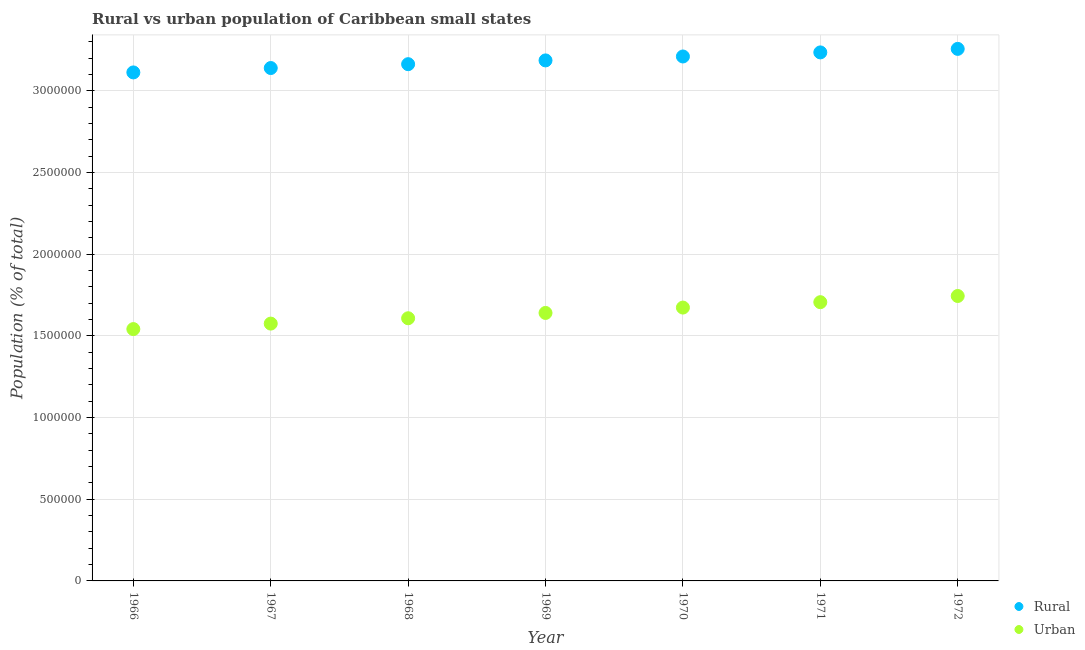What is the rural population density in 1967?
Your response must be concise. 3.14e+06. Across all years, what is the maximum urban population density?
Offer a very short reply. 1.74e+06. Across all years, what is the minimum urban population density?
Offer a terse response. 1.54e+06. In which year was the urban population density minimum?
Your answer should be very brief. 1966. What is the total urban population density in the graph?
Provide a succinct answer. 1.15e+07. What is the difference between the rural population density in 1968 and that in 1972?
Ensure brevity in your answer.  -9.36e+04. What is the difference between the urban population density in 1968 and the rural population density in 1969?
Offer a terse response. -1.58e+06. What is the average rural population density per year?
Your answer should be compact. 3.19e+06. In the year 1970, what is the difference between the rural population density and urban population density?
Provide a short and direct response. 1.54e+06. What is the ratio of the rural population density in 1969 to that in 1972?
Your response must be concise. 0.98. Is the urban population density in 1966 less than that in 1967?
Offer a terse response. Yes. What is the difference between the highest and the second highest rural population density?
Your answer should be very brief. 2.15e+04. What is the difference between the highest and the lowest urban population density?
Your response must be concise. 2.03e+05. In how many years, is the urban population density greater than the average urban population density taken over all years?
Offer a very short reply. 3. Is the sum of the rural population density in 1971 and 1972 greater than the maximum urban population density across all years?
Your answer should be very brief. Yes. Does the rural population density monotonically increase over the years?
Offer a terse response. Yes. How many dotlines are there?
Provide a short and direct response. 2. How many years are there in the graph?
Your answer should be compact. 7. What is the difference between two consecutive major ticks on the Y-axis?
Provide a succinct answer. 5.00e+05. Are the values on the major ticks of Y-axis written in scientific E-notation?
Keep it short and to the point. No. Where does the legend appear in the graph?
Make the answer very short. Bottom right. How many legend labels are there?
Give a very brief answer. 2. How are the legend labels stacked?
Make the answer very short. Vertical. What is the title of the graph?
Offer a terse response. Rural vs urban population of Caribbean small states. Does "Electricity" appear as one of the legend labels in the graph?
Provide a succinct answer. No. What is the label or title of the X-axis?
Give a very brief answer. Year. What is the label or title of the Y-axis?
Offer a very short reply. Population (% of total). What is the Population (% of total) in Rural in 1966?
Ensure brevity in your answer.  3.11e+06. What is the Population (% of total) of Urban in 1966?
Offer a very short reply. 1.54e+06. What is the Population (% of total) of Rural in 1967?
Provide a succinct answer. 3.14e+06. What is the Population (% of total) in Urban in 1967?
Offer a very short reply. 1.57e+06. What is the Population (% of total) of Rural in 1968?
Your response must be concise. 3.16e+06. What is the Population (% of total) of Urban in 1968?
Offer a very short reply. 1.61e+06. What is the Population (% of total) of Rural in 1969?
Provide a short and direct response. 3.19e+06. What is the Population (% of total) of Urban in 1969?
Make the answer very short. 1.64e+06. What is the Population (% of total) of Rural in 1970?
Ensure brevity in your answer.  3.21e+06. What is the Population (% of total) in Urban in 1970?
Make the answer very short. 1.67e+06. What is the Population (% of total) in Rural in 1971?
Offer a very short reply. 3.23e+06. What is the Population (% of total) in Urban in 1971?
Offer a terse response. 1.71e+06. What is the Population (% of total) in Rural in 1972?
Provide a succinct answer. 3.26e+06. What is the Population (% of total) of Urban in 1972?
Provide a short and direct response. 1.74e+06. Across all years, what is the maximum Population (% of total) of Rural?
Make the answer very short. 3.26e+06. Across all years, what is the maximum Population (% of total) in Urban?
Provide a succinct answer. 1.74e+06. Across all years, what is the minimum Population (% of total) in Rural?
Give a very brief answer. 3.11e+06. Across all years, what is the minimum Population (% of total) of Urban?
Your answer should be very brief. 1.54e+06. What is the total Population (% of total) in Rural in the graph?
Your response must be concise. 2.23e+07. What is the total Population (% of total) of Urban in the graph?
Ensure brevity in your answer.  1.15e+07. What is the difference between the Population (% of total) of Rural in 1966 and that in 1967?
Offer a terse response. -2.69e+04. What is the difference between the Population (% of total) of Urban in 1966 and that in 1967?
Keep it short and to the point. -3.36e+04. What is the difference between the Population (% of total) in Rural in 1966 and that in 1968?
Provide a succinct answer. -5.05e+04. What is the difference between the Population (% of total) of Urban in 1966 and that in 1968?
Make the answer very short. -6.63e+04. What is the difference between the Population (% of total) in Rural in 1966 and that in 1969?
Keep it short and to the point. -7.35e+04. What is the difference between the Population (% of total) of Urban in 1966 and that in 1969?
Ensure brevity in your answer.  -9.88e+04. What is the difference between the Population (% of total) in Rural in 1966 and that in 1970?
Your answer should be very brief. -9.76e+04. What is the difference between the Population (% of total) in Urban in 1966 and that in 1970?
Provide a succinct answer. -1.32e+05. What is the difference between the Population (% of total) in Rural in 1966 and that in 1971?
Offer a terse response. -1.23e+05. What is the difference between the Population (% of total) in Urban in 1966 and that in 1971?
Make the answer very short. -1.65e+05. What is the difference between the Population (% of total) of Rural in 1966 and that in 1972?
Make the answer very short. -1.44e+05. What is the difference between the Population (% of total) in Urban in 1966 and that in 1972?
Your answer should be very brief. -2.03e+05. What is the difference between the Population (% of total) in Rural in 1967 and that in 1968?
Offer a very short reply. -2.36e+04. What is the difference between the Population (% of total) of Urban in 1967 and that in 1968?
Offer a terse response. -3.28e+04. What is the difference between the Population (% of total) in Rural in 1967 and that in 1969?
Make the answer very short. -4.67e+04. What is the difference between the Population (% of total) of Urban in 1967 and that in 1969?
Offer a very short reply. -6.53e+04. What is the difference between the Population (% of total) of Rural in 1967 and that in 1970?
Keep it short and to the point. -7.07e+04. What is the difference between the Population (% of total) in Urban in 1967 and that in 1970?
Provide a succinct answer. -9.81e+04. What is the difference between the Population (% of total) of Rural in 1967 and that in 1971?
Your response must be concise. -9.57e+04. What is the difference between the Population (% of total) of Urban in 1967 and that in 1971?
Make the answer very short. -1.31e+05. What is the difference between the Population (% of total) in Rural in 1967 and that in 1972?
Your response must be concise. -1.17e+05. What is the difference between the Population (% of total) of Urban in 1967 and that in 1972?
Provide a short and direct response. -1.69e+05. What is the difference between the Population (% of total) in Rural in 1968 and that in 1969?
Your response must be concise. -2.31e+04. What is the difference between the Population (% of total) in Urban in 1968 and that in 1969?
Ensure brevity in your answer.  -3.25e+04. What is the difference between the Population (% of total) of Rural in 1968 and that in 1970?
Offer a very short reply. -4.71e+04. What is the difference between the Population (% of total) in Urban in 1968 and that in 1970?
Offer a terse response. -6.54e+04. What is the difference between the Population (% of total) in Rural in 1968 and that in 1971?
Your answer should be very brief. -7.20e+04. What is the difference between the Population (% of total) in Urban in 1968 and that in 1971?
Provide a short and direct response. -9.84e+04. What is the difference between the Population (% of total) in Rural in 1968 and that in 1972?
Your response must be concise. -9.36e+04. What is the difference between the Population (% of total) of Urban in 1968 and that in 1972?
Offer a very short reply. -1.36e+05. What is the difference between the Population (% of total) in Rural in 1969 and that in 1970?
Ensure brevity in your answer.  -2.40e+04. What is the difference between the Population (% of total) in Urban in 1969 and that in 1970?
Give a very brief answer. -3.29e+04. What is the difference between the Population (% of total) in Rural in 1969 and that in 1971?
Provide a short and direct response. -4.90e+04. What is the difference between the Population (% of total) in Urban in 1969 and that in 1971?
Your answer should be very brief. -6.58e+04. What is the difference between the Population (% of total) in Rural in 1969 and that in 1972?
Offer a terse response. -7.05e+04. What is the difference between the Population (% of total) of Urban in 1969 and that in 1972?
Offer a very short reply. -1.04e+05. What is the difference between the Population (% of total) in Rural in 1970 and that in 1971?
Ensure brevity in your answer.  -2.50e+04. What is the difference between the Population (% of total) of Urban in 1970 and that in 1971?
Make the answer very short. -3.30e+04. What is the difference between the Population (% of total) in Rural in 1970 and that in 1972?
Your answer should be very brief. -4.65e+04. What is the difference between the Population (% of total) of Urban in 1970 and that in 1972?
Keep it short and to the point. -7.09e+04. What is the difference between the Population (% of total) in Rural in 1971 and that in 1972?
Your response must be concise. -2.15e+04. What is the difference between the Population (% of total) of Urban in 1971 and that in 1972?
Ensure brevity in your answer.  -3.79e+04. What is the difference between the Population (% of total) of Rural in 1966 and the Population (% of total) of Urban in 1967?
Offer a very short reply. 1.54e+06. What is the difference between the Population (% of total) in Rural in 1966 and the Population (% of total) in Urban in 1968?
Keep it short and to the point. 1.50e+06. What is the difference between the Population (% of total) of Rural in 1966 and the Population (% of total) of Urban in 1969?
Your response must be concise. 1.47e+06. What is the difference between the Population (% of total) of Rural in 1966 and the Population (% of total) of Urban in 1970?
Your response must be concise. 1.44e+06. What is the difference between the Population (% of total) in Rural in 1966 and the Population (% of total) in Urban in 1971?
Offer a terse response. 1.41e+06. What is the difference between the Population (% of total) in Rural in 1966 and the Population (% of total) in Urban in 1972?
Your answer should be compact. 1.37e+06. What is the difference between the Population (% of total) of Rural in 1967 and the Population (% of total) of Urban in 1968?
Give a very brief answer. 1.53e+06. What is the difference between the Population (% of total) of Rural in 1967 and the Population (% of total) of Urban in 1969?
Provide a succinct answer. 1.50e+06. What is the difference between the Population (% of total) in Rural in 1967 and the Population (% of total) in Urban in 1970?
Offer a very short reply. 1.47e+06. What is the difference between the Population (% of total) of Rural in 1967 and the Population (% of total) of Urban in 1971?
Keep it short and to the point. 1.43e+06. What is the difference between the Population (% of total) of Rural in 1967 and the Population (% of total) of Urban in 1972?
Your answer should be very brief. 1.40e+06. What is the difference between the Population (% of total) of Rural in 1968 and the Population (% of total) of Urban in 1969?
Provide a short and direct response. 1.52e+06. What is the difference between the Population (% of total) of Rural in 1968 and the Population (% of total) of Urban in 1970?
Keep it short and to the point. 1.49e+06. What is the difference between the Population (% of total) in Rural in 1968 and the Population (% of total) in Urban in 1971?
Make the answer very short. 1.46e+06. What is the difference between the Population (% of total) of Rural in 1968 and the Population (% of total) of Urban in 1972?
Your response must be concise. 1.42e+06. What is the difference between the Population (% of total) in Rural in 1969 and the Population (% of total) in Urban in 1970?
Offer a very short reply. 1.51e+06. What is the difference between the Population (% of total) in Rural in 1969 and the Population (% of total) in Urban in 1971?
Provide a succinct answer. 1.48e+06. What is the difference between the Population (% of total) of Rural in 1969 and the Population (% of total) of Urban in 1972?
Provide a succinct answer. 1.44e+06. What is the difference between the Population (% of total) of Rural in 1970 and the Population (% of total) of Urban in 1971?
Offer a terse response. 1.50e+06. What is the difference between the Population (% of total) in Rural in 1970 and the Population (% of total) in Urban in 1972?
Your answer should be very brief. 1.47e+06. What is the difference between the Population (% of total) of Rural in 1971 and the Population (% of total) of Urban in 1972?
Give a very brief answer. 1.49e+06. What is the average Population (% of total) in Rural per year?
Make the answer very short. 3.19e+06. What is the average Population (% of total) of Urban per year?
Offer a terse response. 1.64e+06. In the year 1966, what is the difference between the Population (% of total) in Rural and Population (% of total) in Urban?
Offer a terse response. 1.57e+06. In the year 1967, what is the difference between the Population (% of total) in Rural and Population (% of total) in Urban?
Your response must be concise. 1.56e+06. In the year 1968, what is the difference between the Population (% of total) in Rural and Population (% of total) in Urban?
Provide a succinct answer. 1.56e+06. In the year 1969, what is the difference between the Population (% of total) in Rural and Population (% of total) in Urban?
Provide a short and direct response. 1.55e+06. In the year 1970, what is the difference between the Population (% of total) in Rural and Population (% of total) in Urban?
Your answer should be compact. 1.54e+06. In the year 1971, what is the difference between the Population (% of total) in Rural and Population (% of total) in Urban?
Provide a succinct answer. 1.53e+06. In the year 1972, what is the difference between the Population (% of total) of Rural and Population (% of total) of Urban?
Give a very brief answer. 1.51e+06. What is the ratio of the Population (% of total) of Rural in 1966 to that in 1967?
Give a very brief answer. 0.99. What is the ratio of the Population (% of total) in Urban in 1966 to that in 1967?
Your answer should be compact. 0.98. What is the ratio of the Population (% of total) in Rural in 1966 to that in 1968?
Your response must be concise. 0.98. What is the ratio of the Population (% of total) in Urban in 1966 to that in 1968?
Offer a terse response. 0.96. What is the ratio of the Population (% of total) of Rural in 1966 to that in 1969?
Make the answer very short. 0.98. What is the ratio of the Population (% of total) of Urban in 1966 to that in 1969?
Offer a very short reply. 0.94. What is the ratio of the Population (% of total) in Rural in 1966 to that in 1970?
Offer a terse response. 0.97. What is the ratio of the Population (% of total) in Urban in 1966 to that in 1970?
Give a very brief answer. 0.92. What is the ratio of the Population (% of total) of Rural in 1966 to that in 1971?
Ensure brevity in your answer.  0.96. What is the ratio of the Population (% of total) of Urban in 1966 to that in 1971?
Give a very brief answer. 0.9. What is the ratio of the Population (% of total) of Rural in 1966 to that in 1972?
Give a very brief answer. 0.96. What is the ratio of the Population (% of total) in Urban in 1966 to that in 1972?
Keep it short and to the point. 0.88. What is the ratio of the Population (% of total) in Urban in 1967 to that in 1968?
Provide a succinct answer. 0.98. What is the ratio of the Population (% of total) of Urban in 1967 to that in 1969?
Provide a succinct answer. 0.96. What is the ratio of the Population (% of total) in Rural in 1967 to that in 1970?
Ensure brevity in your answer.  0.98. What is the ratio of the Population (% of total) of Urban in 1967 to that in 1970?
Provide a succinct answer. 0.94. What is the ratio of the Population (% of total) in Rural in 1967 to that in 1971?
Provide a succinct answer. 0.97. What is the ratio of the Population (% of total) in Urban in 1967 to that in 1971?
Give a very brief answer. 0.92. What is the ratio of the Population (% of total) in Rural in 1967 to that in 1972?
Keep it short and to the point. 0.96. What is the ratio of the Population (% of total) in Urban in 1967 to that in 1972?
Offer a terse response. 0.9. What is the ratio of the Population (% of total) of Urban in 1968 to that in 1969?
Make the answer very short. 0.98. What is the ratio of the Population (% of total) in Urban in 1968 to that in 1970?
Your answer should be compact. 0.96. What is the ratio of the Population (% of total) in Rural in 1968 to that in 1971?
Your answer should be compact. 0.98. What is the ratio of the Population (% of total) of Urban in 1968 to that in 1971?
Offer a terse response. 0.94. What is the ratio of the Population (% of total) of Rural in 1968 to that in 1972?
Make the answer very short. 0.97. What is the ratio of the Population (% of total) in Urban in 1968 to that in 1972?
Keep it short and to the point. 0.92. What is the ratio of the Population (% of total) of Rural in 1969 to that in 1970?
Keep it short and to the point. 0.99. What is the ratio of the Population (% of total) of Urban in 1969 to that in 1970?
Offer a very short reply. 0.98. What is the ratio of the Population (% of total) of Rural in 1969 to that in 1971?
Your response must be concise. 0.98. What is the ratio of the Population (% of total) in Urban in 1969 to that in 1971?
Give a very brief answer. 0.96. What is the ratio of the Population (% of total) of Rural in 1969 to that in 1972?
Ensure brevity in your answer.  0.98. What is the ratio of the Population (% of total) in Urban in 1969 to that in 1972?
Your answer should be compact. 0.94. What is the ratio of the Population (% of total) of Rural in 1970 to that in 1971?
Give a very brief answer. 0.99. What is the ratio of the Population (% of total) in Urban in 1970 to that in 1971?
Provide a short and direct response. 0.98. What is the ratio of the Population (% of total) in Rural in 1970 to that in 1972?
Your answer should be compact. 0.99. What is the ratio of the Population (% of total) of Urban in 1970 to that in 1972?
Your response must be concise. 0.96. What is the ratio of the Population (% of total) in Urban in 1971 to that in 1972?
Provide a succinct answer. 0.98. What is the difference between the highest and the second highest Population (% of total) of Rural?
Your answer should be compact. 2.15e+04. What is the difference between the highest and the second highest Population (% of total) of Urban?
Keep it short and to the point. 3.79e+04. What is the difference between the highest and the lowest Population (% of total) of Rural?
Make the answer very short. 1.44e+05. What is the difference between the highest and the lowest Population (% of total) in Urban?
Your answer should be very brief. 2.03e+05. 